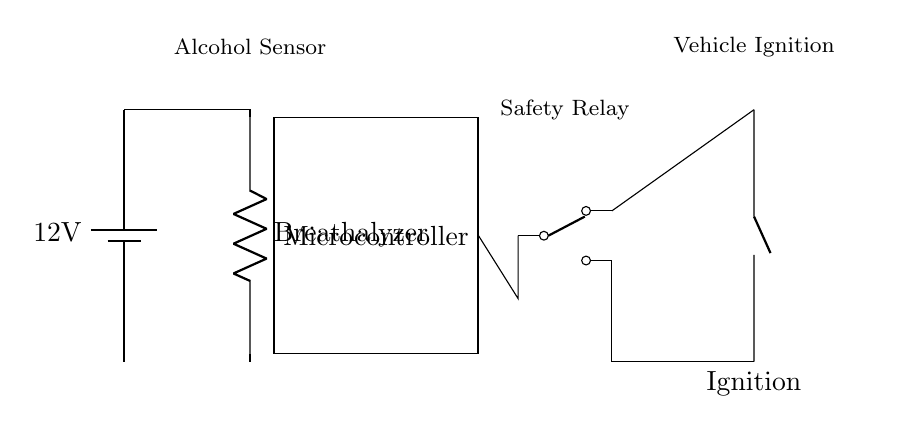What is the voltage of this circuit? The voltage is 12 volts, indicated by the battery symbol at the beginning of the circuit which shows the power supply voltage.
Answer: 12 volts What component measures alcohol content? The component designated as "Breathalyzer" is responsible for measuring the level of alcohol content in the breath, as indicated in the circuit diagram.
Answer: Breathalyzer What connects the breathalyzer to the microcontroller? The breathalyzer is connected to the microcontroller by direct wiring lines that show a clear path from the breathalyzer output to the mcu input.
Answer: Wiring lines How many outputs does the relay have? The relay has two outputs, which can be observed as it has two distinct output nodes leading to the ignition connection, indicating switching capabilities.
Answer: Two outputs How does the microcontroller interact with the ignition? The microcontroller processes the input from the breathalyzer and controls the relay, which then impacts the ignition by either enabling or disabling it depending on alcohol levels.
Answer: Through relay control What safety feature is used in this circuit? The safety relay acts as a switch that prevents the ignition from being activated unless conditions from the breathalyzer are met, ensuring safety by preventing impaired driving.
Answer: Safety relay 